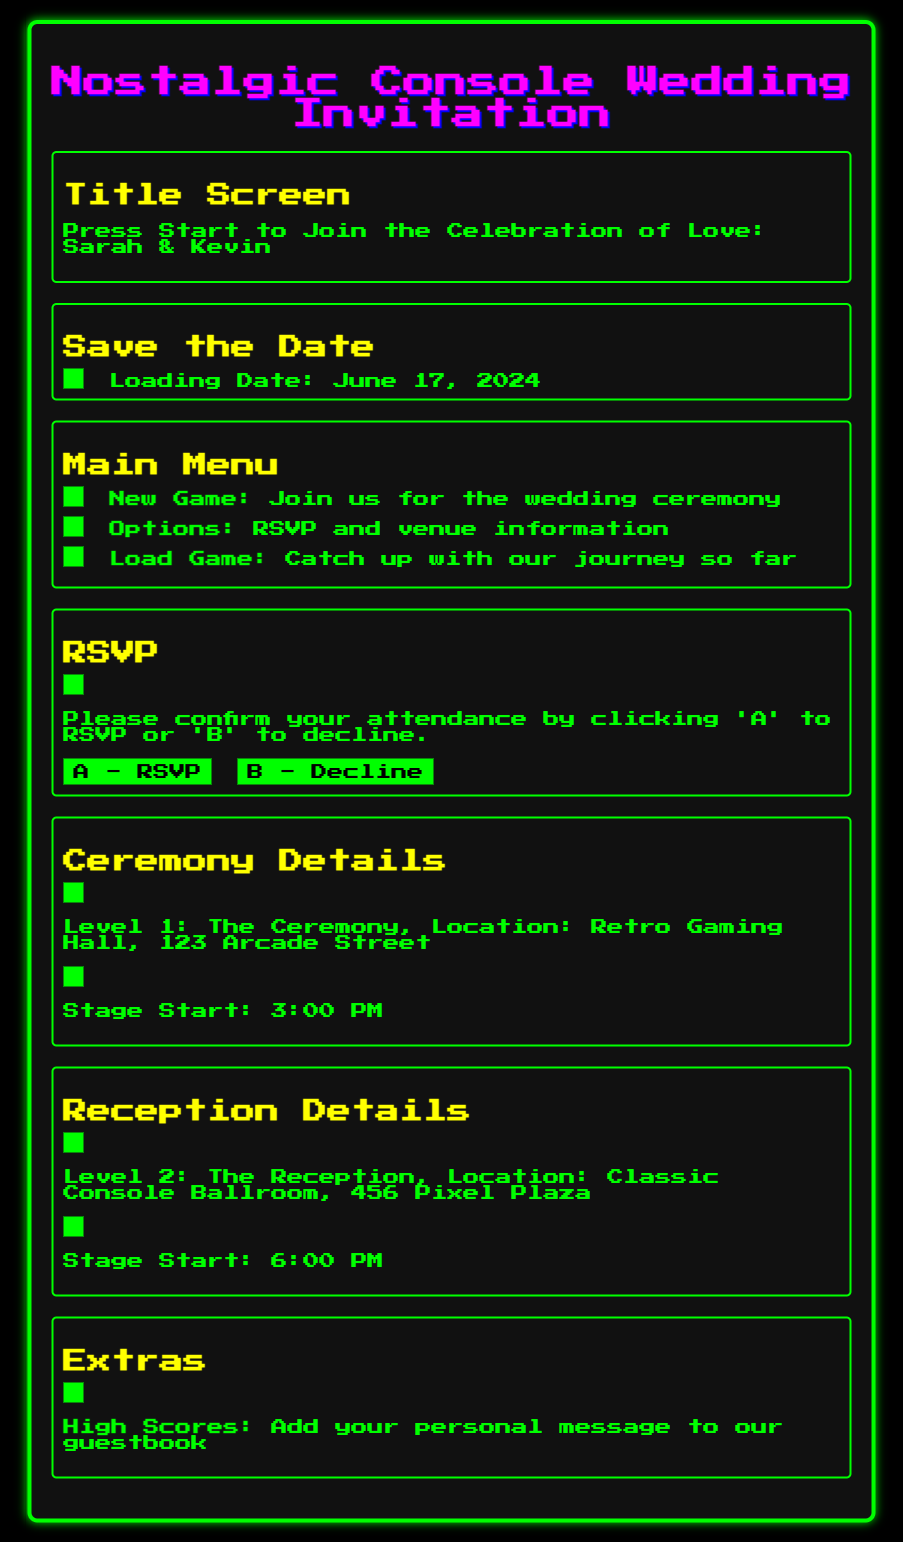What are the names of the couple? The invite mentions the couple's names in the "Title Screen" section, which states "Sarah & Kevin."
Answer: Sarah & Kevin When is the wedding date? The save-the-date section specifies the wedding date as "June 17, 2024."
Answer: June 17, 2024 What time does the ceremony start? The "Ceremony Details" section indicates the ceremony starts at "3:00 PM."
Answer: 3:00 PM Where is the wedding ceremony located? In the "Ceremony Details," it states the location as "Retro Gaming Hall, 123 Arcade Street."
Answer: Retro Gaming Hall, 123 Arcade Street What option allows you to RSVP? The "RSVP" section includes options labeled "A - RSVP" for confirming attendance.
Answer: A - RSVP What is the second level mentioned in the document? The "Reception Details" section refers to "Level 2: The Reception."
Answer: Level 2: The Reception What kind of personal interaction is encouraged in the "Extras" section? The document suggests adding a personal message to a guestbook under "High Scores."
Answer: High Scores How many main sections are there in this invitation? Counting the sections mentioned: Title Screen, Save the Date, Main Menu, RSVP, Ceremony Details, Reception Details, Extras results in seven sections.
Answer: Seven 